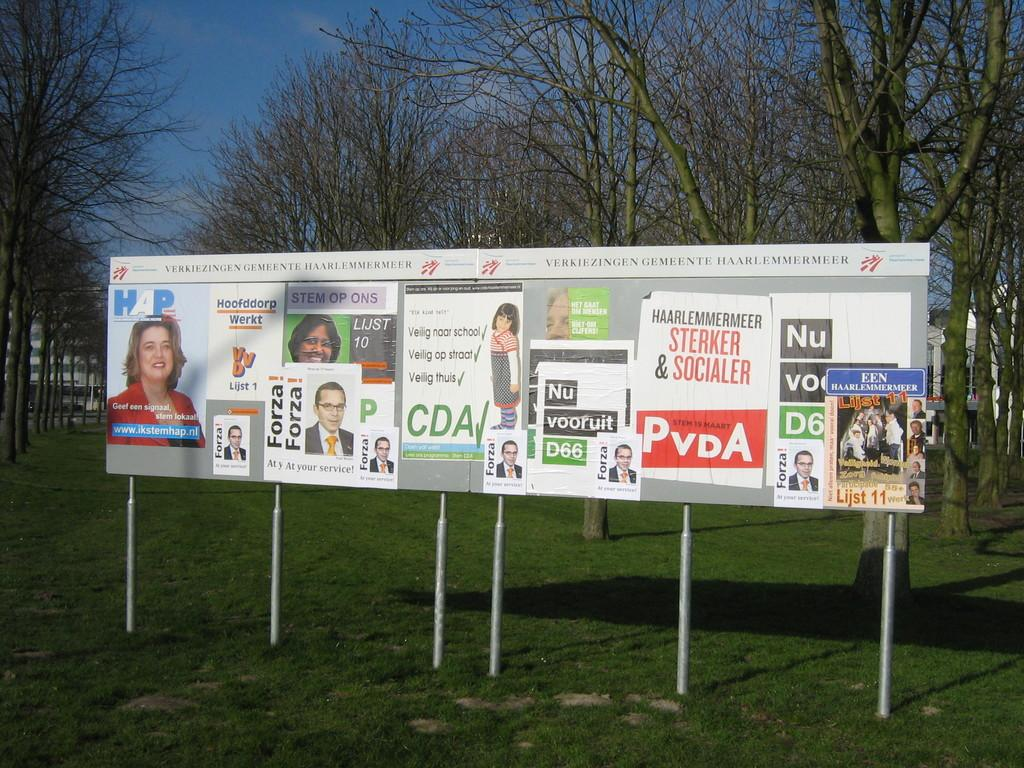<image>
Render a clear and concise summary of the photo. Political posters for politicians named Forza and Lijst, among others, are pasted to some signboards. 